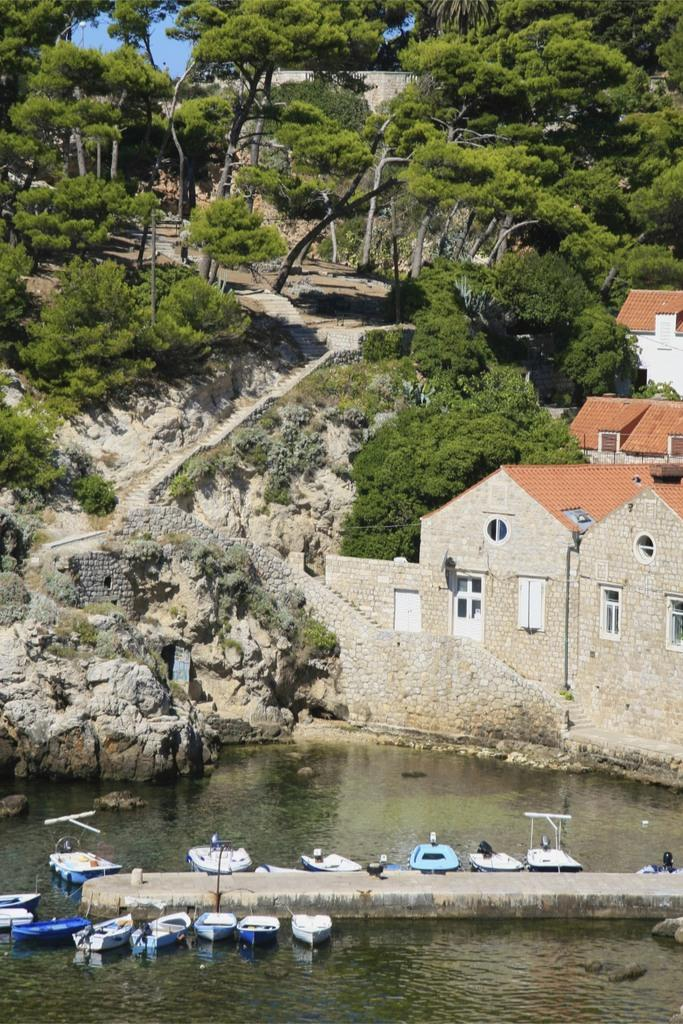What is the main element in the image? There is water in the image. What is floating on the water? There are boats in the water. What can be seen in the background of the image? There are rock hills with steps, trees, and houses with windows in the background. What type of vase can be seen on the boats in the image? There is no vase present on the boats in the image. What route are the boats taking in the image? The image does not provide information about the route the boats are taking. 